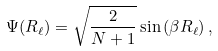Convert formula to latex. <formula><loc_0><loc_0><loc_500><loc_500>\Psi ( R _ { \ell } ) = \sqrt { \frac { 2 } { N + 1 } } \sin \left ( \beta R _ { \ell } \right ) ,</formula> 